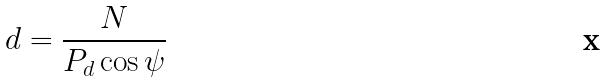<formula> <loc_0><loc_0><loc_500><loc_500>d = \frac { N } { P _ { d } \cos \psi }</formula> 